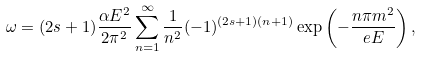Convert formula to latex. <formula><loc_0><loc_0><loc_500><loc_500>\omega = ( 2 s + 1 ) \frac { \alpha E ^ { 2 } } { 2 \pi ^ { 2 } } \sum _ { n = 1 } ^ { \infty } \frac { 1 } { n ^ { 2 } } ( - 1 ) ^ { ( 2 s + 1 ) ( n + 1 ) } \exp \left ( - \frac { n \pi m ^ { 2 } } { e E } \right ) ,</formula> 